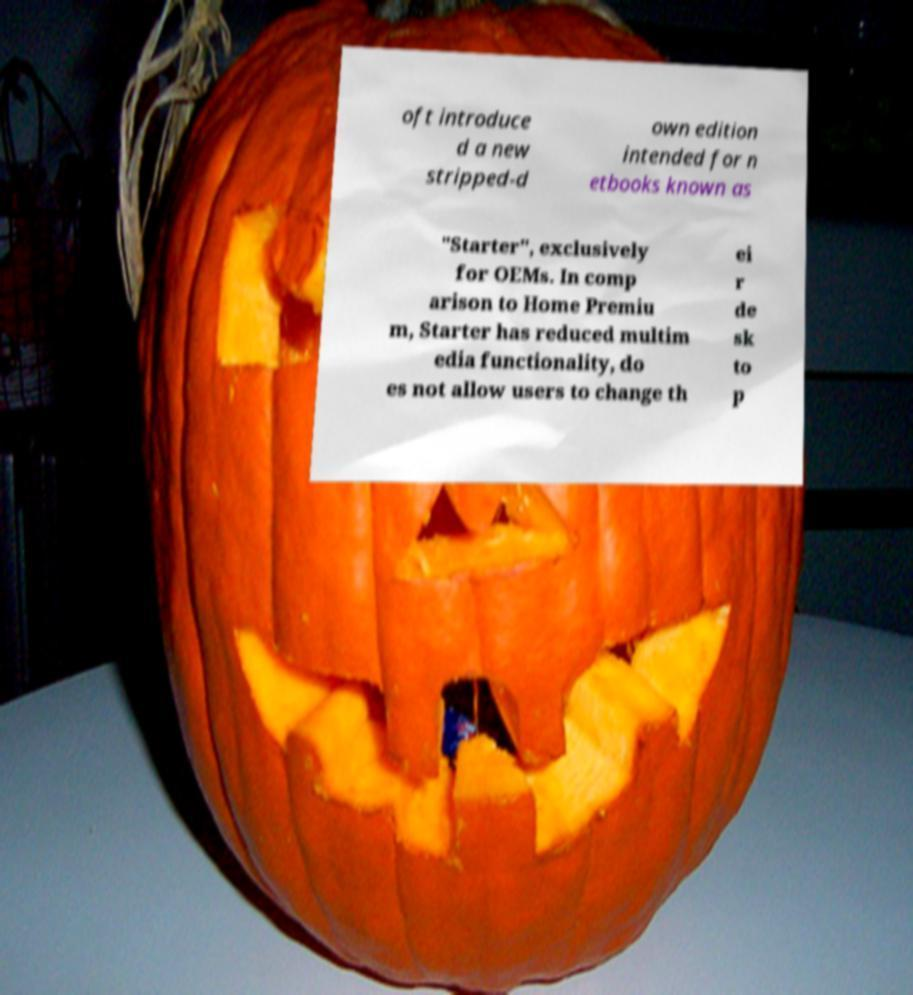There's text embedded in this image that I need extracted. Can you transcribe it verbatim? oft introduce d a new stripped-d own edition intended for n etbooks known as "Starter", exclusively for OEMs. In comp arison to Home Premiu m, Starter has reduced multim edia functionality, do es not allow users to change th ei r de sk to p 